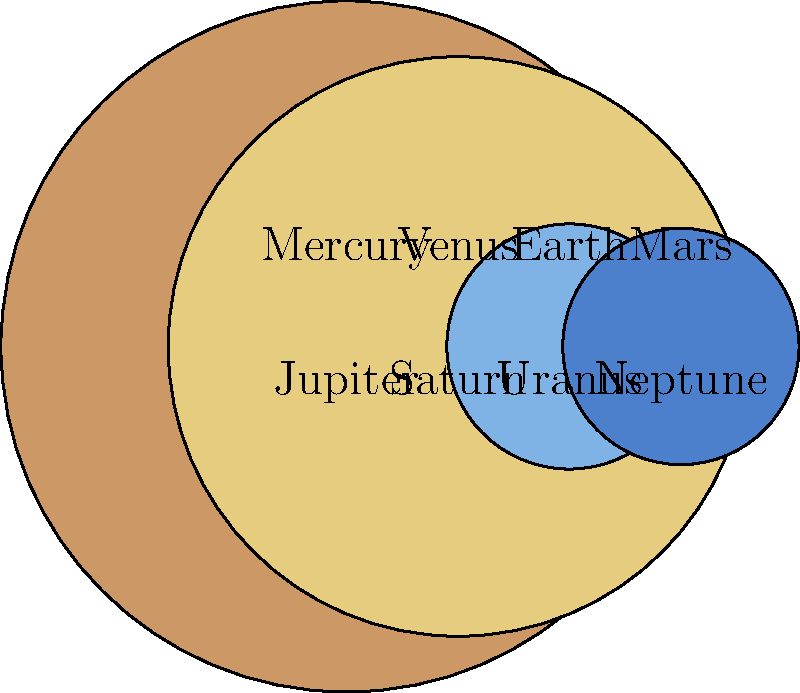In the diagram, the planets of our solar system are represented by scaled circles. Which planet has a diameter approximately 11 times larger than Earth's? To answer this question, we need to compare the sizes of the planets in the diagram:

1. First, identify Earth in the diagram (the blue circle in the top row).
2. Visually compare Earth's size to the other planets.
3. Jupiter and Saturn are significantly larger than the other planets.
4. Measure or estimate the diameter of Jupiter and Saturn relative to Earth.
5. Jupiter's diameter is about 11 times larger than Earth's in the diagram.
6. Saturn's diameter is slightly smaller than Jupiter's, about 9-10 times Earth's diameter.

The planet with a diameter approximately 11 times larger than Earth's is Jupiter. This representation is accurate, as Jupiter's actual diameter is about 11.2 times that of Earth.

As an ambassador whose life has been transformed by astronomy education, you can use this visual comparison to explain the vast size differences in our solar system, emphasizing how such scaled representations help us understand planetary relationships.
Answer: Jupiter 